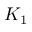Convert formula to latex. <formula><loc_0><loc_0><loc_500><loc_500>K _ { 1 }</formula> 